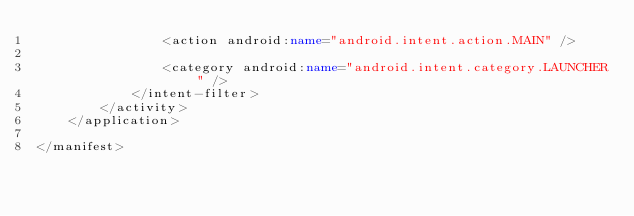<code> <loc_0><loc_0><loc_500><loc_500><_XML_>                <action android:name="android.intent.action.MAIN" />

                <category android:name="android.intent.category.LAUNCHER" />
            </intent-filter>
        </activity>
    </application>

</manifest></code> 